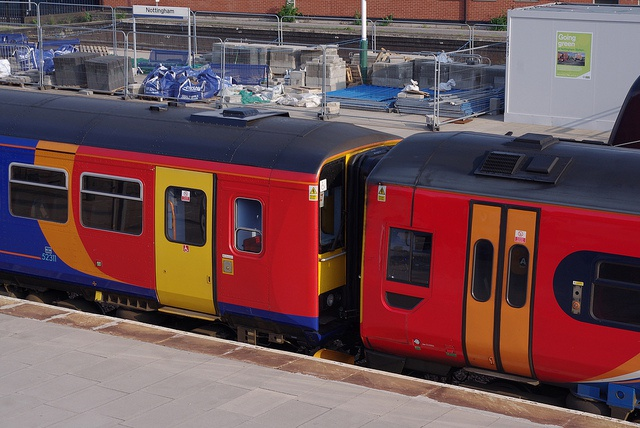Describe the objects in this image and their specific colors. I can see a train in navy, black, and brown tones in this image. 